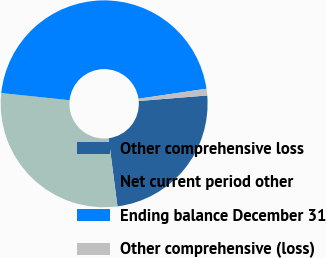Convert chart to OTSL. <chart><loc_0><loc_0><loc_500><loc_500><pie_chart><fcel>Other comprehensive loss<fcel>Net current period other<fcel>Ending balance December 31<fcel>Other comprehensive (loss)<nl><fcel>24.23%<fcel>28.72%<fcel>46.01%<fcel>1.04%<nl></chart> 